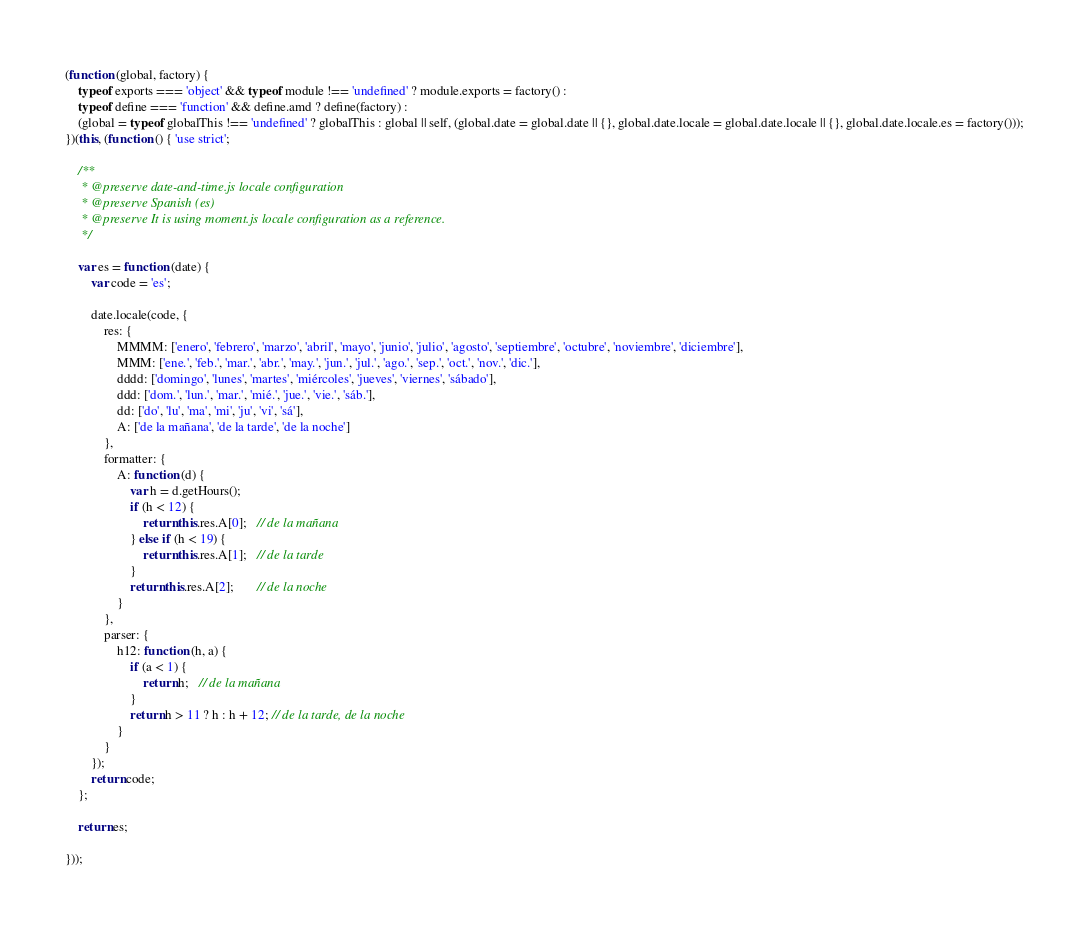<code> <loc_0><loc_0><loc_500><loc_500><_JavaScript_>(function (global, factory) {
    typeof exports === 'object' && typeof module !== 'undefined' ? module.exports = factory() :
    typeof define === 'function' && define.amd ? define(factory) :
    (global = typeof globalThis !== 'undefined' ? globalThis : global || self, (global.date = global.date || {}, global.date.locale = global.date.locale || {}, global.date.locale.es = factory()));
})(this, (function () { 'use strict';

    /**
     * @preserve date-and-time.js locale configuration
     * @preserve Spanish (es)
     * @preserve It is using moment.js locale configuration as a reference.
     */

    var es = function (date) {
        var code = 'es';

        date.locale(code, {
            res: {
                MMMM: ['enero', 'febrero', 'marzo', 'abril', 'mayo', 'junio', 'julio', 'agosto', 'septiembre', 'octubre', 'noviembre', 'diciembre'],
                MMM: ['ene.', 'feb.', 'mar.', 'abr.', 'may.', 'jun.', 'jul.', 'ago.', 'sep.', 'oct.', 'nov.', 'dic.'],
                dddd: ['domingo', 'lunes', 'martes', 'miércoles', 'jueves', 'viernes', 'sábado'],
                ddd: ['dom.', 'lun.', 'mar.', 'mié.', 'jue.', 'vie.', 'sáb.'],
                dd: ['do', 'lu', 'ma', 'mi', 'ju', 'vi', 'sá'],
                A: ['de la mañana', 'de la tarde', 'de la noche']
            },
            formatter: {
                A: function (d) {
                    var h = d.getHours();
                    if (h < 12) {
                        return this.res.A[0];   // de la mañana
                    } else if (h < 19) {
                        return this.res.A[1];   // de la tarde
                    }
                    return this.res.A[2];       // de la noche
                }
            },
            parser: {
                h12: function (h, a) {
                    if (a < 1) {
                        return h;   // de la mañana
                    }
                    return h > 11 ? h : h + 12; // de la tarde, de la noche
                }
            }
        });
        return code;
    };

    return es;

}));
</code> 